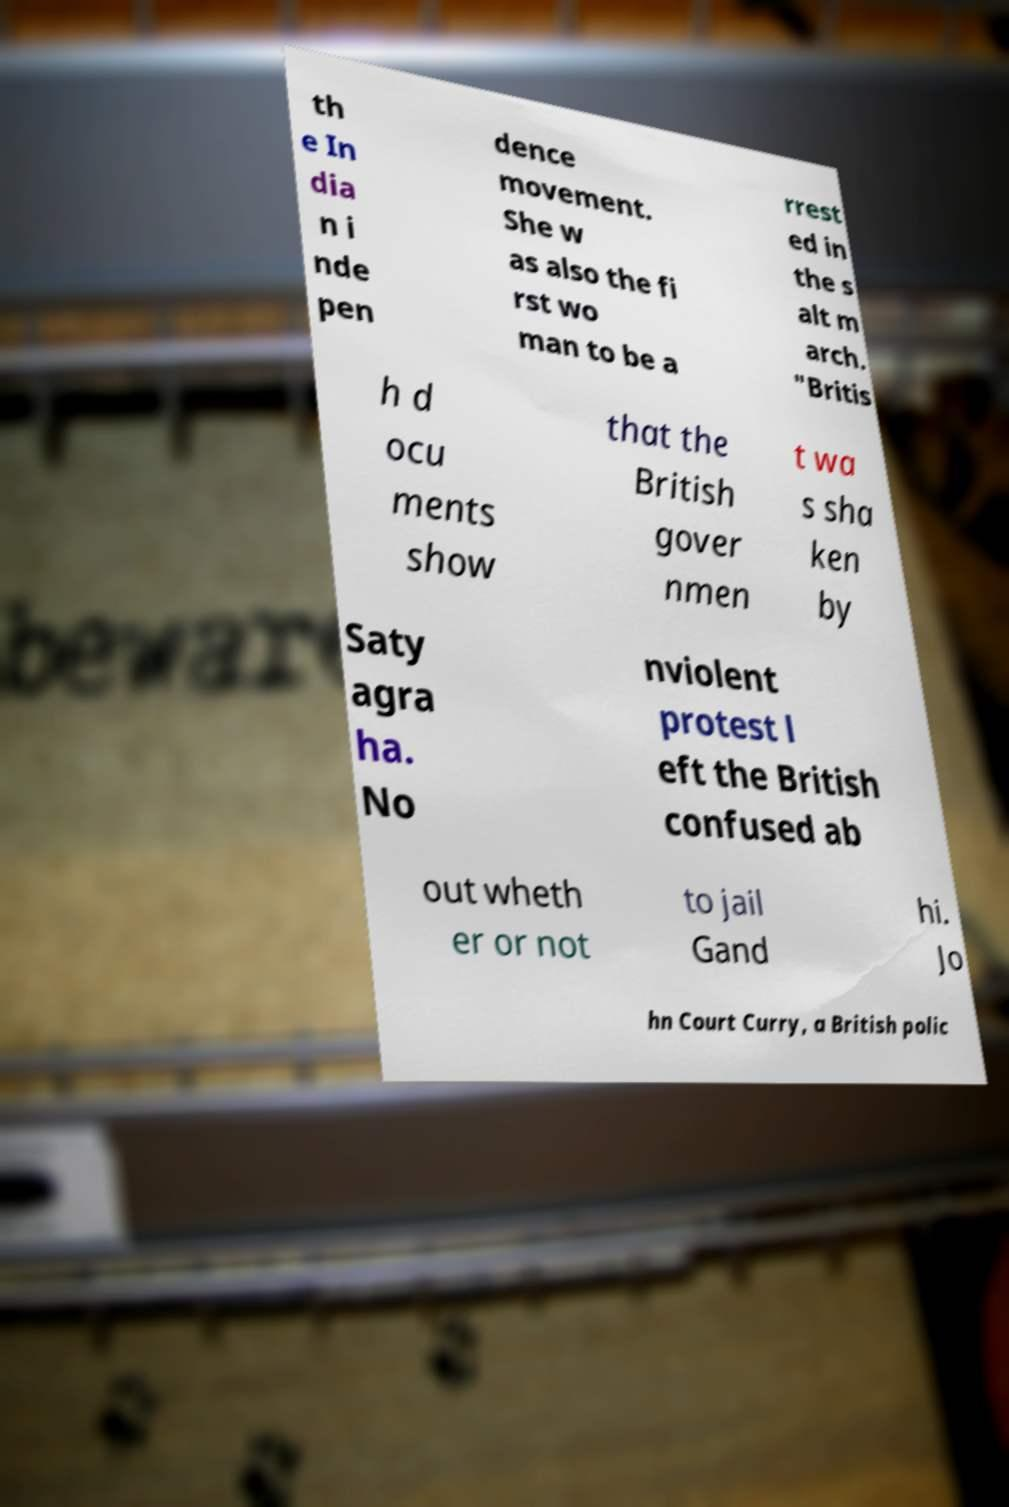Please identify and transcribe the text found in this image. th e In dia n i nde pen dence movement. She w as also the fi rst wo man to be a rrest ed in the s alt m arch. "Britis h d ocu ments show that the British gover nmen t wa s sha ken by Saty agra ha. No nviolent protest l eft the British confused ab out wheth er or not to jail Gand hi. Jo hn Court Curry, a British polic 